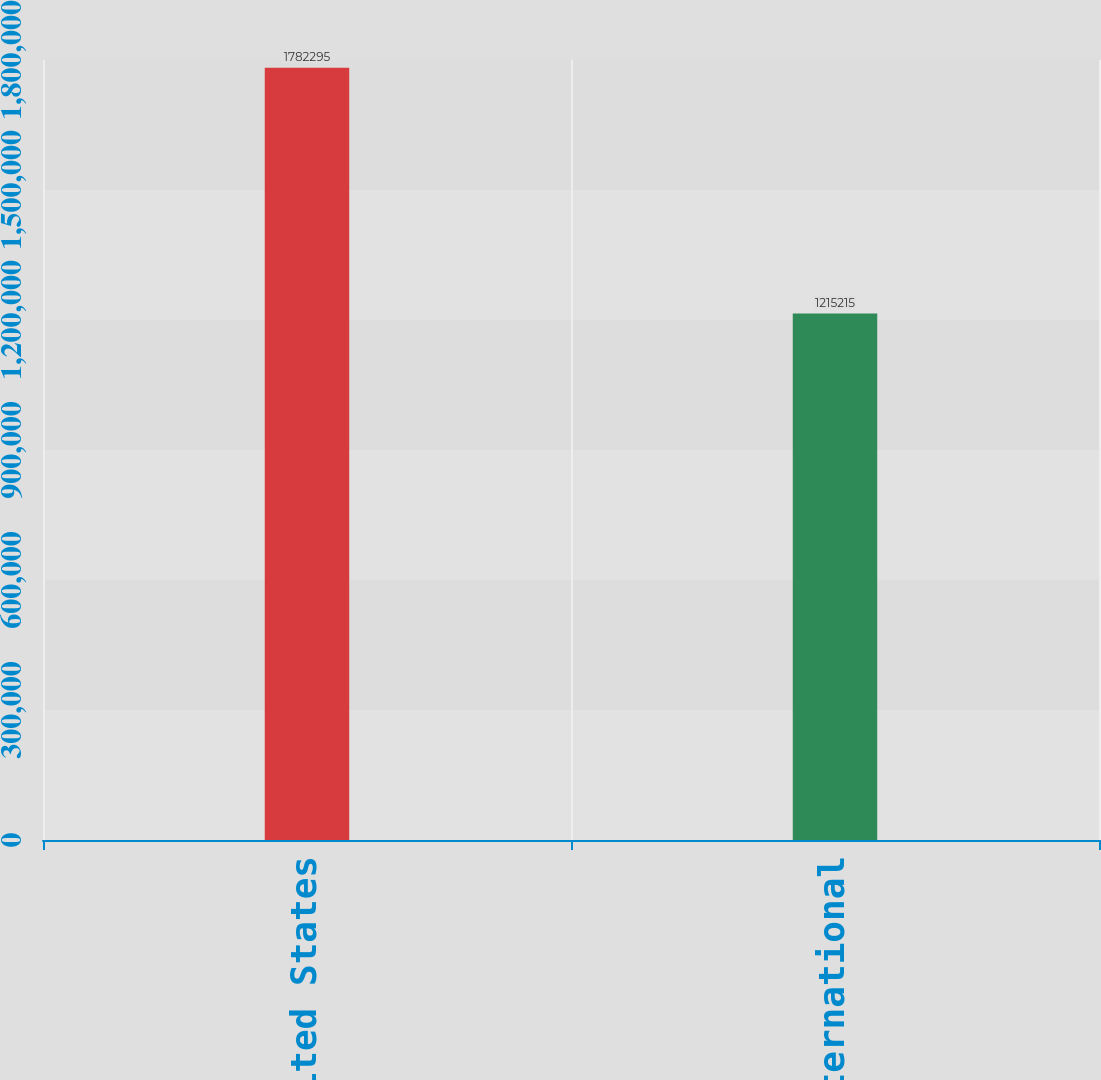Convert chart. <chart><loc_0><loc_0><loc_500><loc_500><bar_chart><fcel>United States<fcel>International<nl><fcel>1.7823e+06<fcel>1.21522e+06<nl></chart> 